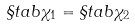Convert formula to latex. <formula><loc_0><loc_0><loc_500><loc_500>\S t a b \chi _ { 1 } = \S t a b \chi _ { 2 }</formula> 